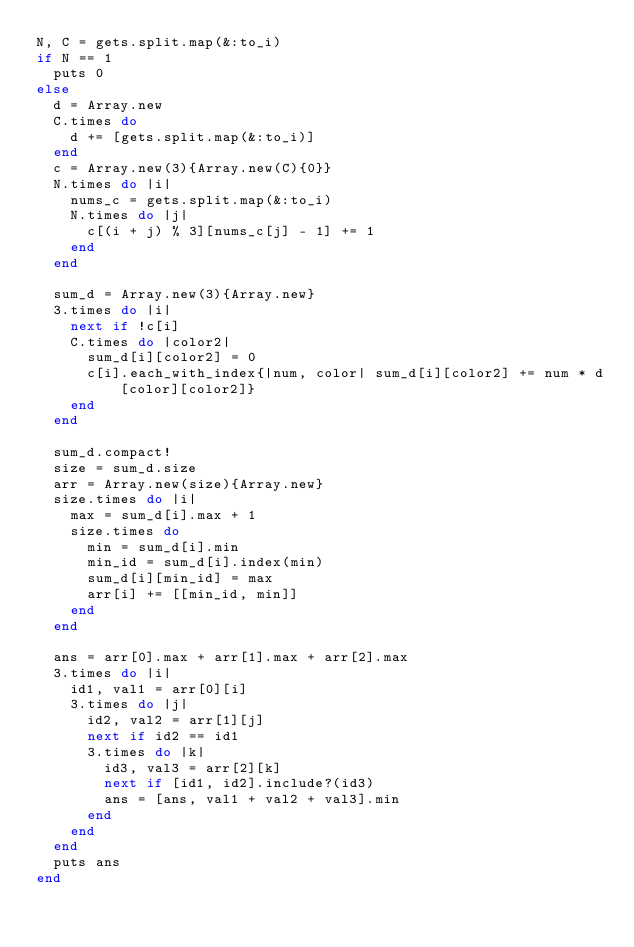Convert code to text. <code><loc_0><loc_0><loc_500><loc_500><_Ruby_>N, C = gets.split.map(&:to_i)
if N == 1
  puts 0
else
  d = Array.new
  C.times do
    d += [gets.split.map(&:to_i)]
  end
  c = Array.new(3){Array.new(C){0}}
  N.times do |i|
    nums_c = gets.split.map(&:to_i)
    N.times do |j|
      c[(i + j) % 3][nums_c[j] - 1] += 1
    end
  end

  sum_d = Array.new(3){Array.new}
  3.times do |i|
    next if !c[i]
    C.times do |color2|
      sum_d[i][color2] = 0
      c[i].each_with_index{|num, color| sum_d[i][color2] += num * d[color][color2]}
    end
  end

  sum_d.compact!
  size = sum_d.size
  arr = Array.new(size){Array.new}
  size.times do |i|
    max = sum_d[i].max + 1
    size.times do
      min = sum_d[i].min
      min_id = sum_d[i].index(min)
      sum_d[i][min_id] = max
      arr[i] += [[min_id, min]]
    end
  end

  ans = arr[0].max + arr[1].max + arr[2].max
  3.times do |i|
    id1, val1 = arr[0][i]
    3.times do |j|
      id2, val2 = arr[1][j]
      next if id2 == id1
      3.times do |k|
        id3, val3 = arr[2][k]
        next if [id1, id2].include?(id3)
        ans = [ans, val1 + val2 + val3].min
      end
    end
  end
  puts ans
end</code> 